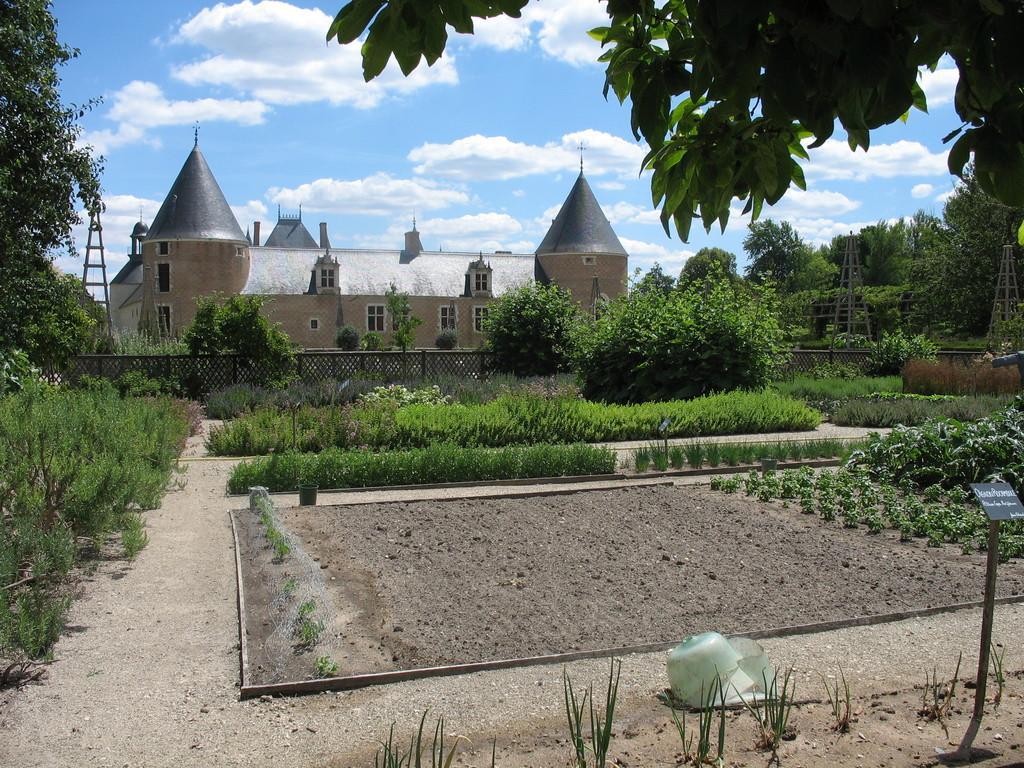Describe this image in one or two sentences. In this picture, there is a castle towards the top left. In the center, there are plants, field etc. The entire picture is covered with the trees and plants. On the top, there is a sky with clouds. 